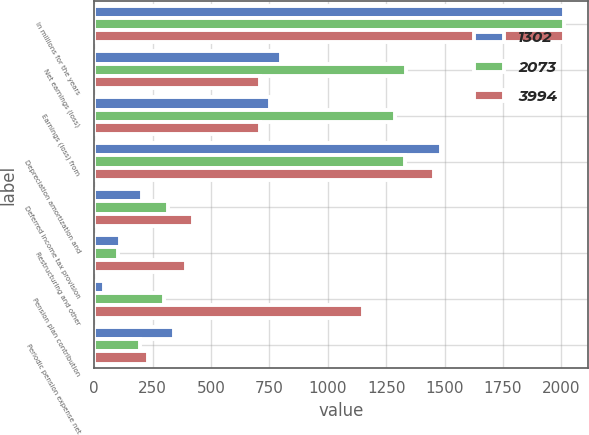Convert chart. <chart><loc_0><loc_0><loc_500><loc_500><stacked_bar_chart><ecel><fcel>In millions for the years<fcel>Net earnings (loss)<fcel>Earnings (loss) from<fcel>Depreciation amortization and<fcel>Deferred income tax provision<fcel>Restructuring and other<fcel>Pension plan contribution<fcel>Periodic pension expense net<nl><fcel>1302<fcel>2012<fcel>799<fcel>754<fcel>1486<fcel>204<fcel>109<fcel>44<fcel>342<nl><fcel>2073<fcel>2011<fcel>1336<fcel>1287<fcel>1332<fcel>317<fcel>102<fcel>300<fcel>195<nl><fcel>3994<fcel>2010<fcel>712<fcel>712<fcel>1456<fcel>422<fcel>394<fcel>1150<fcel>231<nl></chart> 